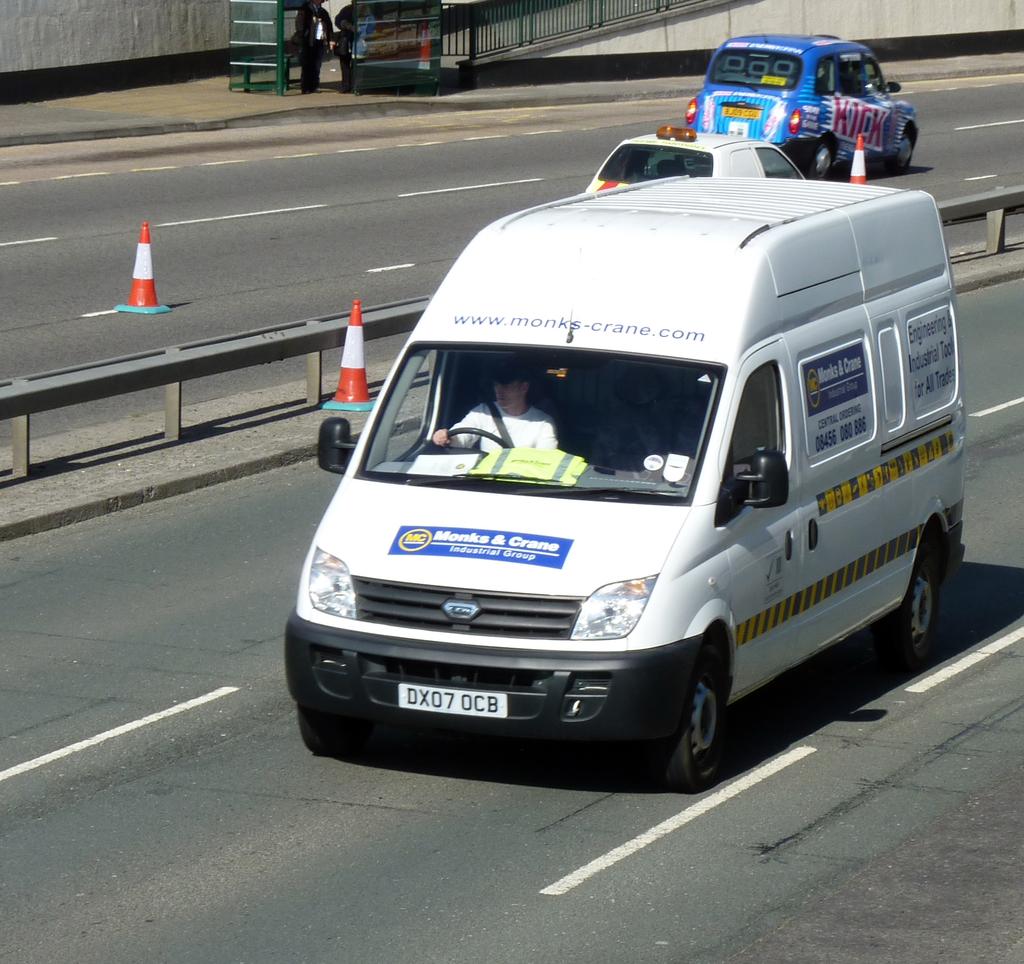What is the licence plate number of the white van?
Your response must be concise. Dx07ocb. What website is advertised on the van?
Your response must be concise. Www.monks-crane.com. 